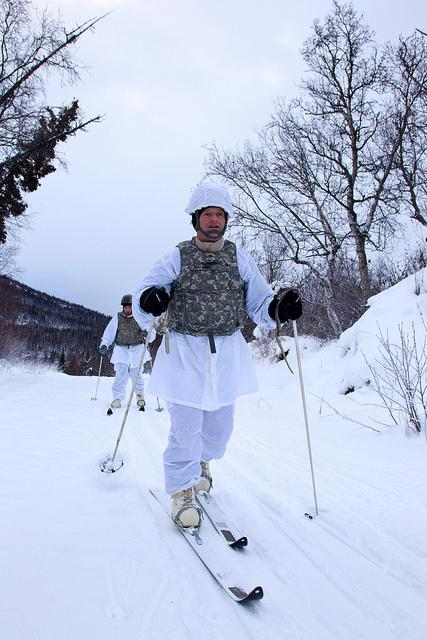Why does he have on that type of vest? warmth 